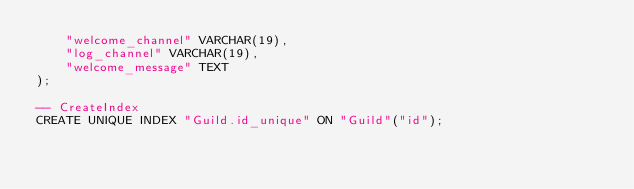Convert code to text. <code><loc_0><loc_0><loc_500><loc_500><_SQL_>    "welcome_channel" VARCHAR(19),
    "log_channel" VARCHAR(19),
    "welcome_message" TEXT
);

-- CreateIndex
CREATE UNIQUE INDEX "Guild.id_unique" ON "Guild"("id");
</code> 